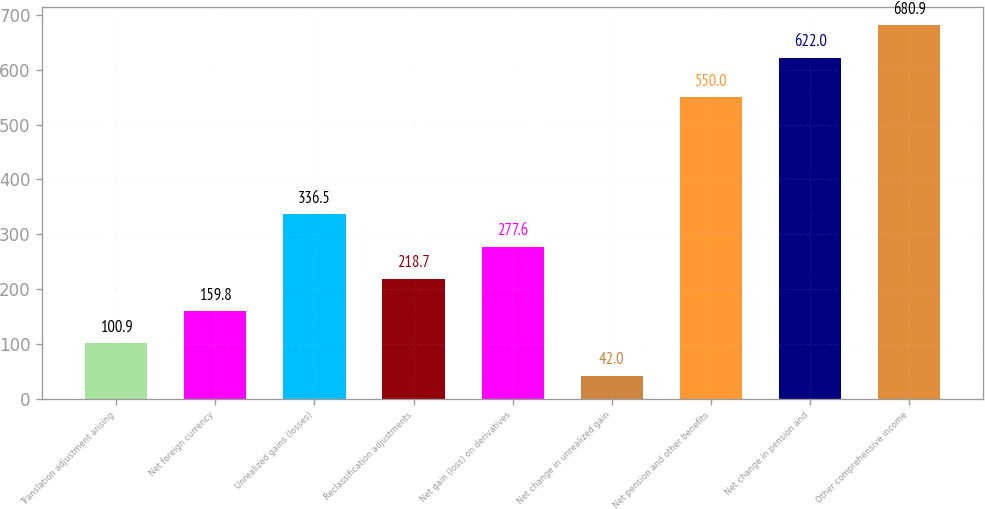Convert chart to OTSL. <chart><loc_0><loc_0><loc_500><loc_500><bar_chart><fcel>Translation adjustment arising<fcel>Net foreign currency<fcel>Unrealized gains (losses)<fcel>Reclassification adjustments<fcel>Net gain (loss) on derivatives<fcel>Net change in unrealized gain<fcel>Net pension and other benefits<fcel>Net change in pension and<fcel>Other comprehensive income<nl><fcel>100.9<fcel>159.8<fcel>336.5<fcel>218.7<fcel>277.6<fcel>42<fcel>550<fcel>622<fcel>680.9<nl></chart> 